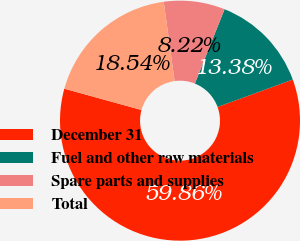Convert chart. <chart><loc_0><loc_0><loc_500><loc_500><pie_chart><fcel>December 31<fcel>Fuel and other raw materials<fcel>Spare parts and supplies<fcel>Total<nl><fcel>59.86%<fcel>13.38%<fcel>8.22%<fcel>18.54%<nl></chart> 